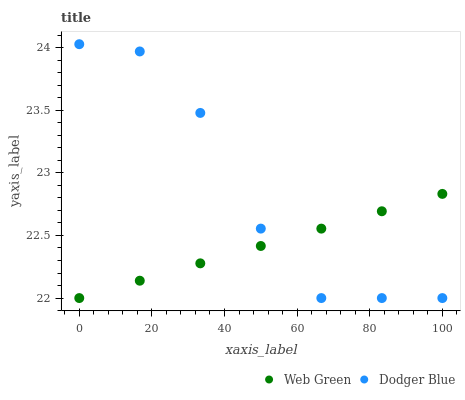Does Web Green have the minimum area under the curve?
Answer yes or no. Yes. Does Dodger Blue have the maximum area under the curve?
Answer yes or no. Yes. Does Web Green have the maximum area under the curve?
Answer yes or no. No. Is Web Green the smoothest?
Answer yes or no. Yes. Is Dodger Blue the roughest?
Answer yes or no. Yes. Is Web Green the roughest?
Answer yes or no. No. Does Dodger Blue have the lowest value?
Answer yes or no. Yes. Does Dodger Blue have the highest value?
Answer yes or no. Yes. Does Web Green have the highest value?
Answer yes or no. No. Does Web Green intersect Dodger Blue?
Answer yes or no. Yes. Is Web Green less than Dodger Blue?
Answer yes or no. No. Is Web Green greater than Dodger Blue?
Answer yes or no. No. 